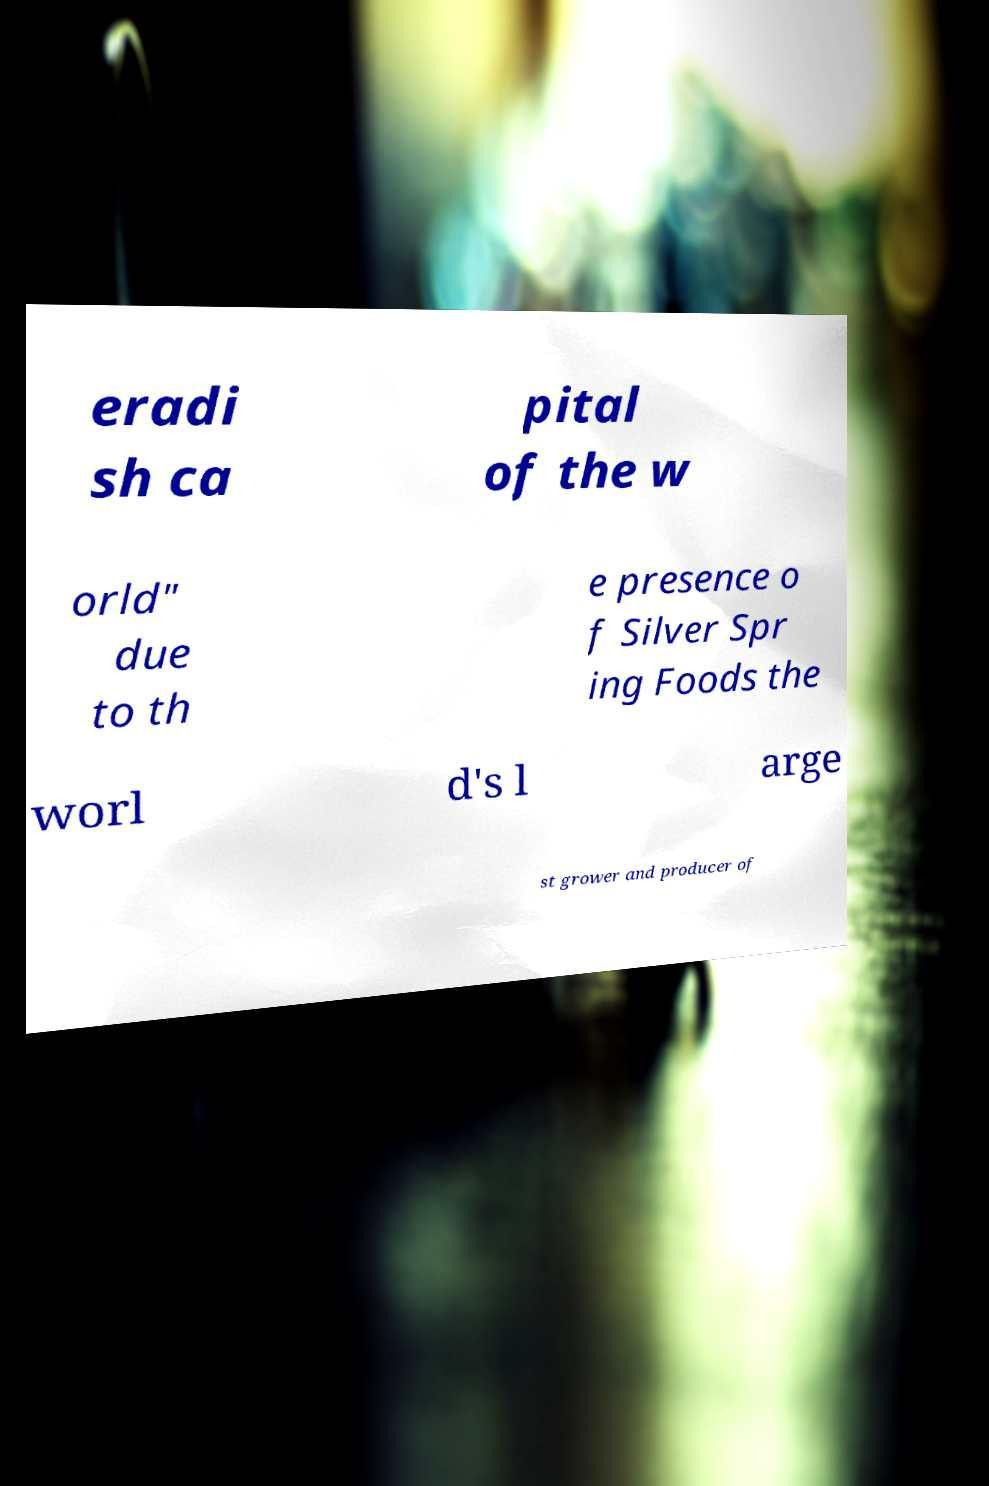There's text embedded in this image that I need extracted. Can you transcribe it verbatim? eradi sh ca pital of the w orld" due to th e presence o f Silver Spr ing Foods the worl d's l arge st grower and producer of 